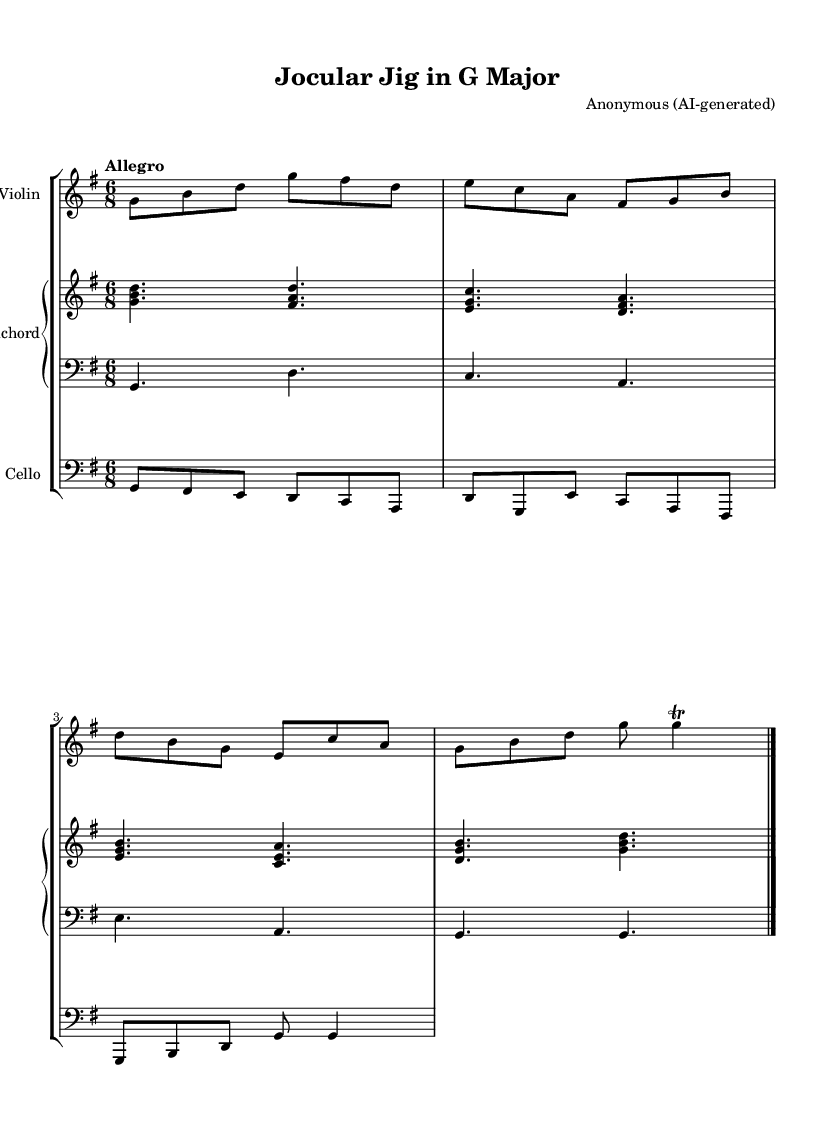What is the key signature of this music? The key signature shows one sharp, which indicates that the piece is in G major.
Answer: G major What is the time signature of this piece? The time signature is 6/8, meaning there are six eighth notes in each measure.
Answer: 6/8 What is the tempo marking for the piece? The tempo marking is "Allegro," which indicates a fast and lively tempo.
Answer: Allegro How many beats are in each measure? Each measure contains six eighth notes, so there are six beats in total per measure.
Answer: Six What type of ensemble is this piece written for? The score is written for a small ensemble including violin, cello, and harpsichord.
Answer: Small ensemble What is the rhythmic feel of this piece? The piece has a lively, compound meter feel typical of jigs in Baroque music, emphasized by the triplet feel of the 6/8 time signature.
Answer: Lively jig How many parts are in this composition? There are four distinct parts: violin, cello, and two staves for the harpsichord.
Answer: Four parts 